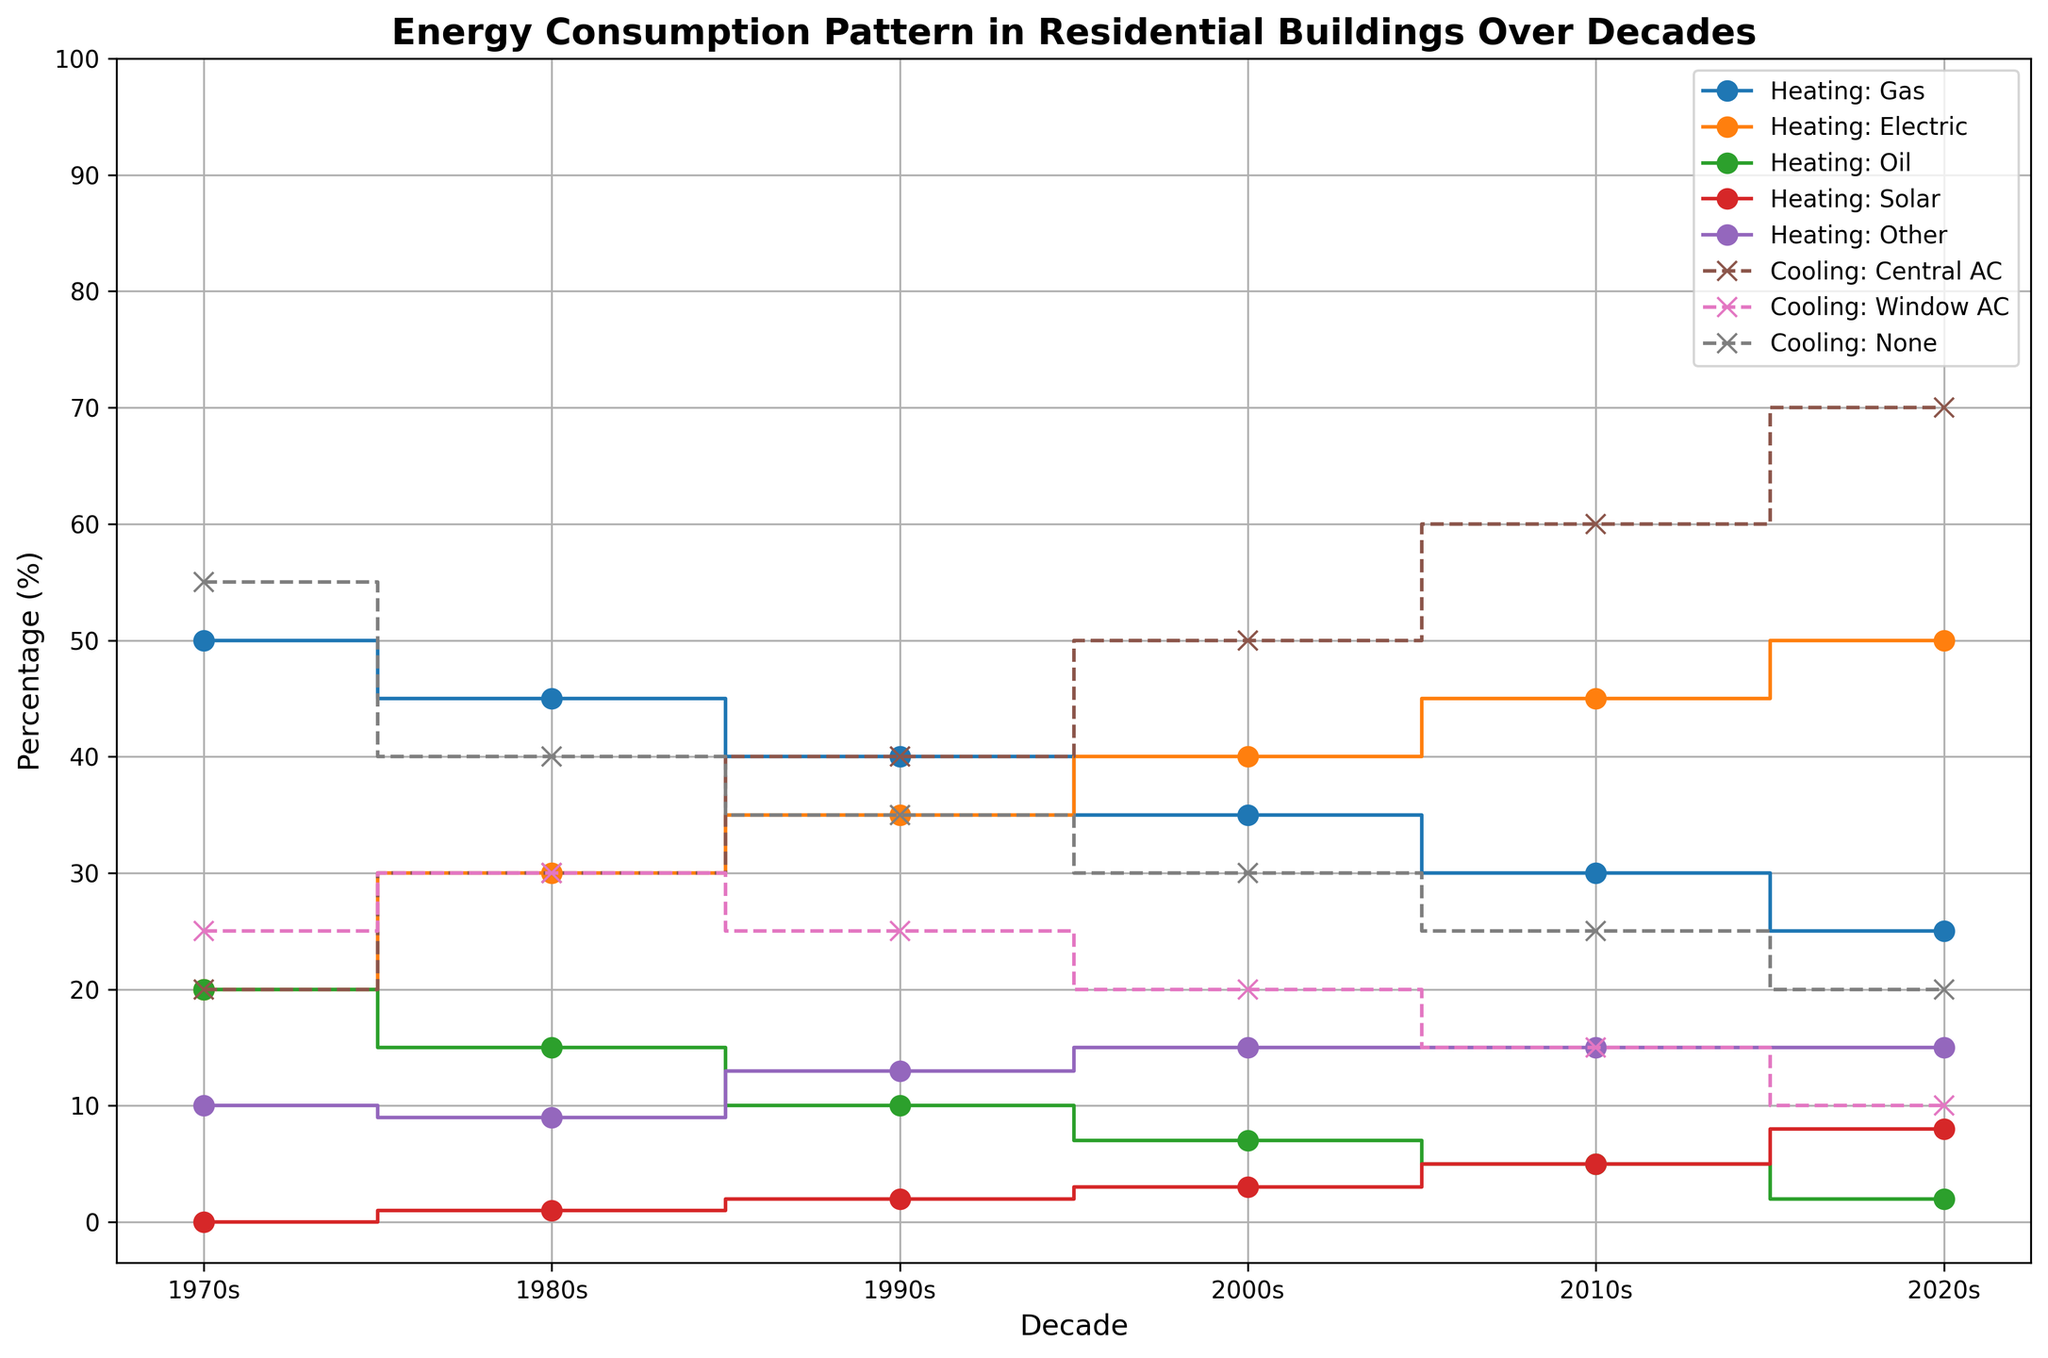What heating method has shown the greatest decline from the 1970s to the 2020s? Compare the percentage of each method in the 1970s and the 2020s. Gas heating decreased from 50% to 25%, which is the largest decline (a 25 percentage point drop).
Answer: Heating: Gas Which cooling method increased the most from the 1970s to the 2020s? Compare the percentage of each cooling method in the 1970s and the 2020s. Central AC increased from 20% to 70%, marking the most significant rise (a 50 percentage point increase).
Answer: Cooling: Central AC What was the percentage change for electric heating from the 1980s to the 2010s? Electric heating increased from 30% to 45%. To find the percentage change: ((45-30) / 30) * 100 = 50%.
Answer: 50% Which decade had the highest combined percentage for heating methods other than gas and electric? Sum the percentages of Heating: Oil, Heating: Solar, and Heating: Other for each decade. The highest combined total is in the 2020s (2+8+15=25%).
Answer: 2020s In which decade did Cooling: Window AC first start to decline, and by how much? Compare Cooling: Window AC stats for each decade, noting the first decline. It decreased from 35% in the 1990s to 30% in the 2000s, a 5 percentage point drop.
Answer: 2000s, 5% By how much did the percentage of residences not using any cooling method decrease from the 1970s to the 2020s? Compare the percentages for Cooling: None in 1970 (55%) and 2020 (20%). The decrease is 55% - 20% = 35%.
Answer: 35% Which decade saw the smallest change in Heating: Gas percentage compared to its previous decade? Compare percentage changes for Heating: Gas between consecutive decades. The smallest change was in the 2010s (30%) compared to the 2000s (35%), a change of 5 percentage points.
Answer: 2010s What is the average percentage of Heating: Solar over all decades? Sum the Heating: Solar percentages for all decades (0+1+2+3+5+8 = 19), then divide by 6 (number of decades): 19/6 ≈ 3.17%.
Answer: 3.17% 